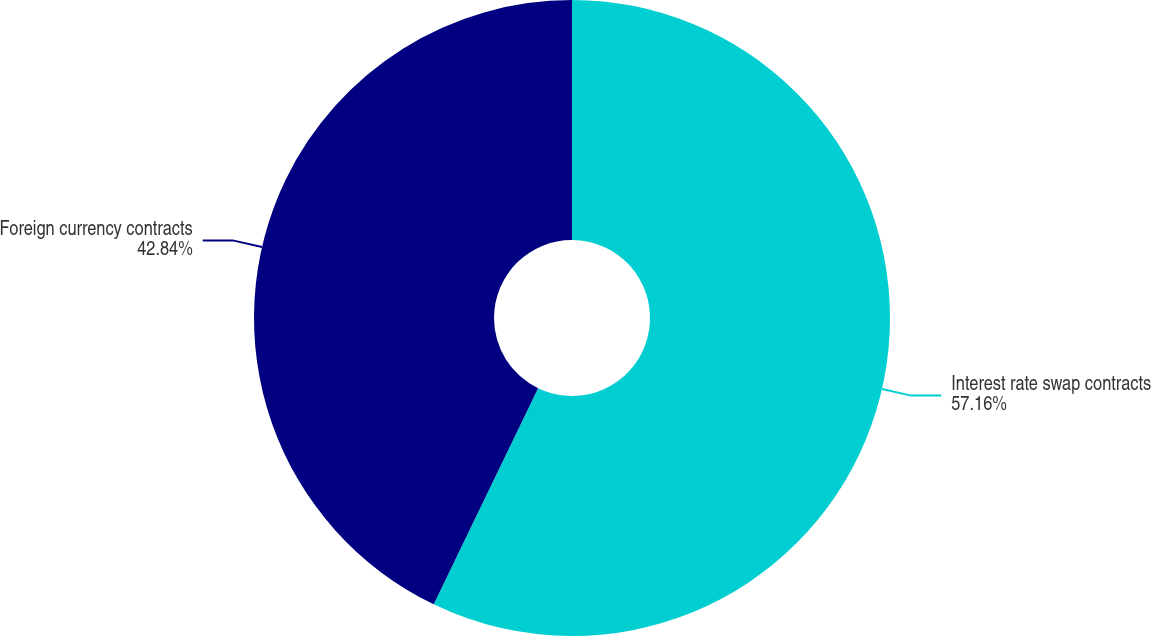Convert chart to OTSL. <chart><loc_0><loc_0><loc_500><loc_500><pie_chart><fcel>Interest rate swap contracts<fcel>Foreign currency contracts<nl><fcel>57.16%<fcel>42.84%<nl></chart> 